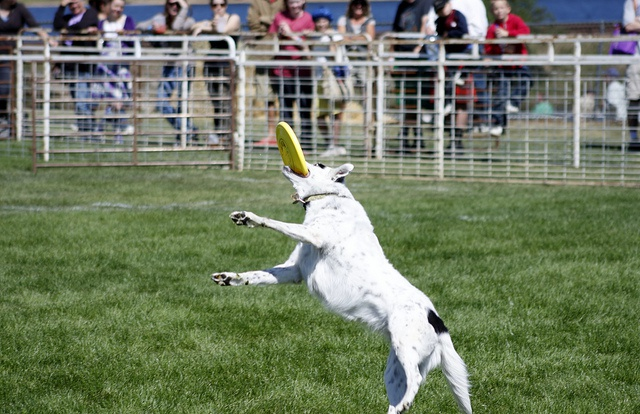Describe the objects in this image and their specific colors. I can see dog in black, white, gray, darkgray, and olive tones, people in black, gray, and darkgray tones, people in black, gray, darkgray, and maroon tones, people in black, gray, darkgray, and lightgray tones, and people in black, darkgray, gray, and lightgray tones in this image. 